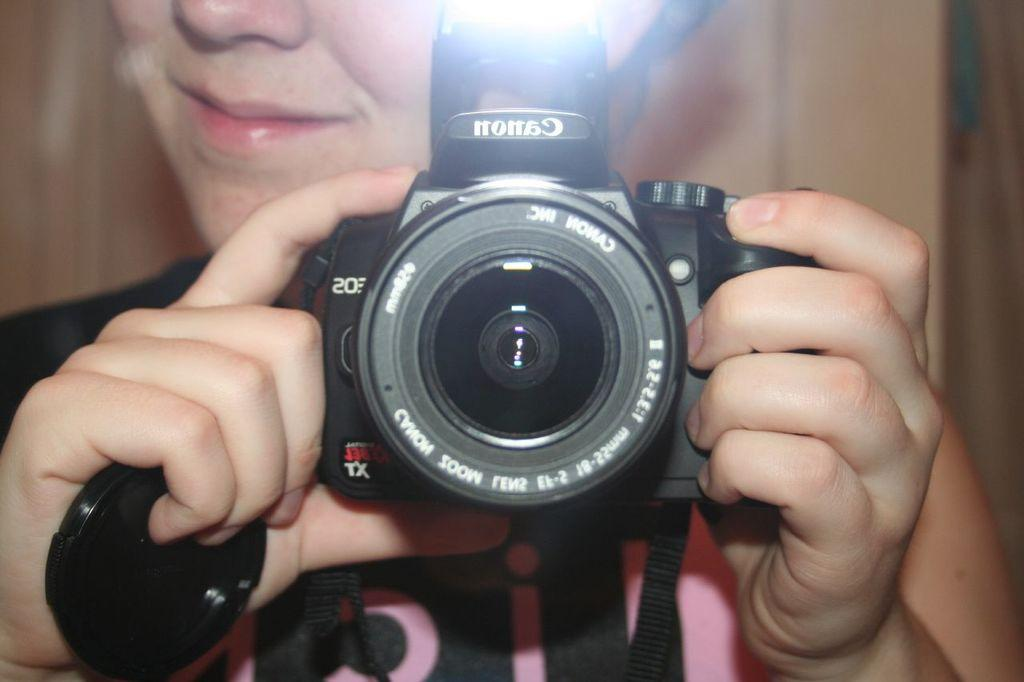What is the main subject of the image? There is a person in the center of the image. What is the person holding in his hand? The person is holding a camera in his hand. Where is the office located in the image? There is no office present in the image. What type of playground equipment can be seen in the image? There is no playground equipment present in the image. 